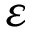Convert formula to latex. <formula><loc_0><loc_0><loc_500><loc_500>\varepsilon</formula> 